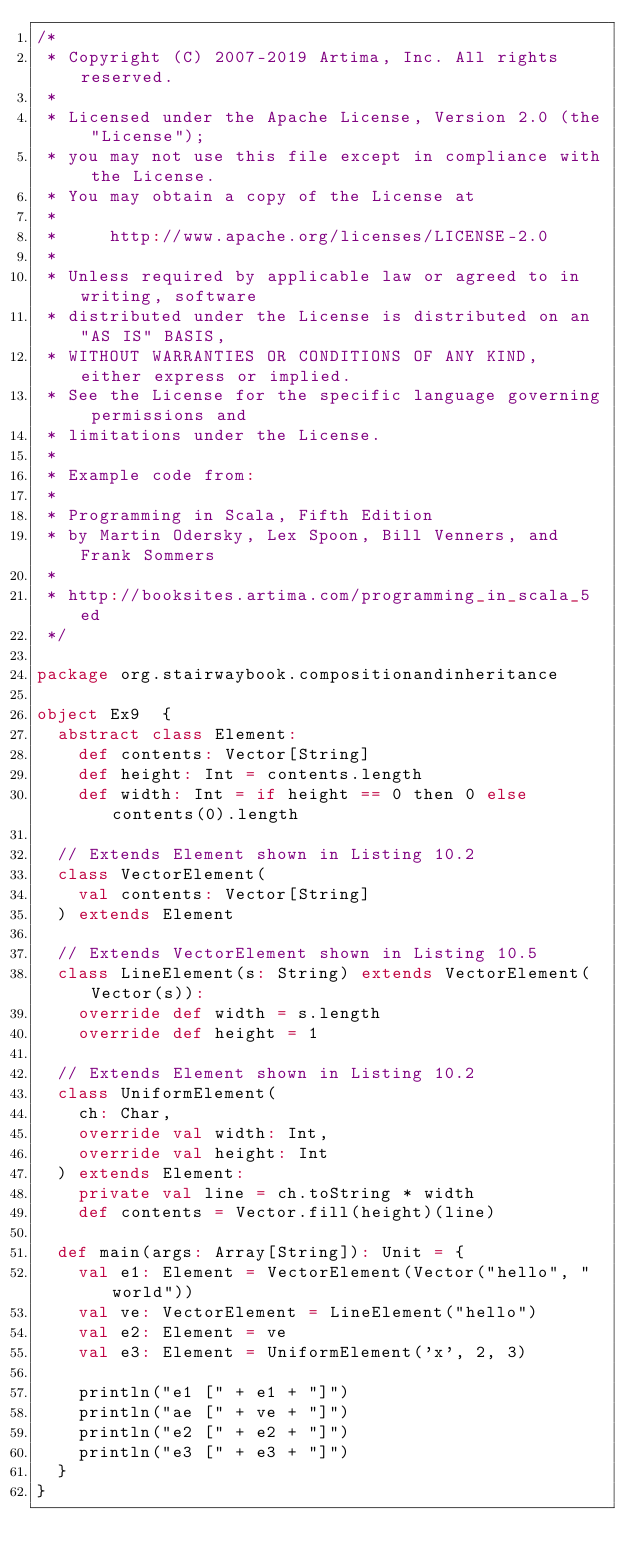Convert code to text. <code><loc_0><loc_0><loc_500><loc_500><_Scala_>/*
 * Copyright (C) 2007-2019 Artima, Inc. All rights reserved.
 * 
 * Licensed under the Apache License, Version 2.0 (the "License");
 * you may not use this file except in compliance with the License.
 * You may obtain a copy of the License at
 * 
 *     http://www.apache.org/licenses/LICENSE-2.0
 * 
 * Unless required by applicable law or agreed to in writing, software
 * distributed under the License is distributed on an "AS IS" BASIS,
 * WITHOUT WARRANTIES OR CONDITIONS OF ANY KIND, either express or implied.
 * See the License for the specific language governing permissions and
 * limitations under the License.
 *
 * Example code from:
 *
 * Programming in Scala, Fifth Edition
 * by Martin Odersky, Lex Spoon, Bill Venners, and Frank Sommers
 *
 * http://booksites.artima.com/programming_in_scala_5ed
 */

package org.stairwaybook.compositionandinheritance

object Ex9  {
  abstract class Element:
    def contents: Vector[String]
    def height: Int = contents.length
    def width: Int = if height == 0 then 0 else contents(0).length

  // Extends Element shown in Listing 10.2
  class VectorElement(
    val contents: Vector[String]
  ) extends Element

  // Extends VectorElement shown in Listing 10.5
  class LineElement(s: String) extends VectorElement(Vector(s)):
    override def width = s.length
    override def height = 1

  // Extends Element shown in Listing 10.2
  class UniformElement(
    ch: Char, 
    override val width: Int,
    override val height: Int 
  ) extends Element:
    private val line = ch.toString * width
    def contents = Vector.fill(height)(line)

  def main(args: Array[String]): Unit = {
    val e1: Element = VectorElement(Vector("hello", "world"))
    val ve: VectorElement = LineElement("hello")
    val e2: Element = ve
    val e3: Element = UniformElement('x', 2, 3)

    println("e1 [" + e1 + "]")
    println("ae [" + ve + "]")
    println("e2 [" + e2 + "]")
    println("e3 [" + e3 + "]")
  }
}
</code> 